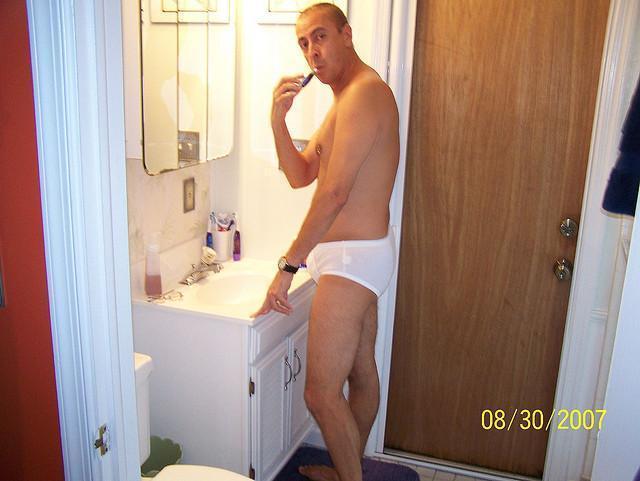How many locks are on the door?
Give a very brief answer. 2. 